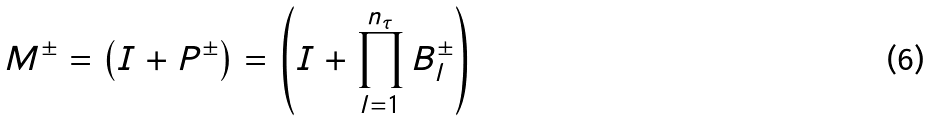Convert formula to latex. <formula><loc_0><loc_0><loc_500><loc_500>M ^ { \pm } = \left ( I + P ^ { \pm } \right ) = \left ( I + \prod _ { l = 1 } ^ { n _ { \tau } } B _ { l } ^ { \pm } \right )</formula> 